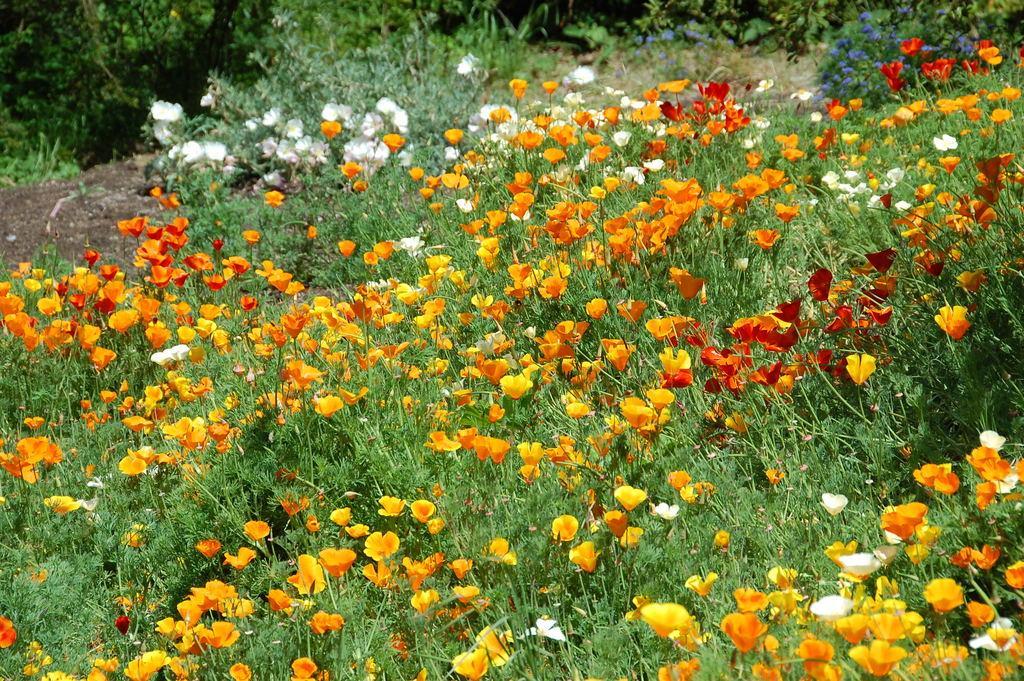Could you give a brief overview of what you see in this image? In this picture I can observe orange, yellow, red and white color flowers to the plants. On the right side I can observe violet color flowers. In the background there are some plants. 